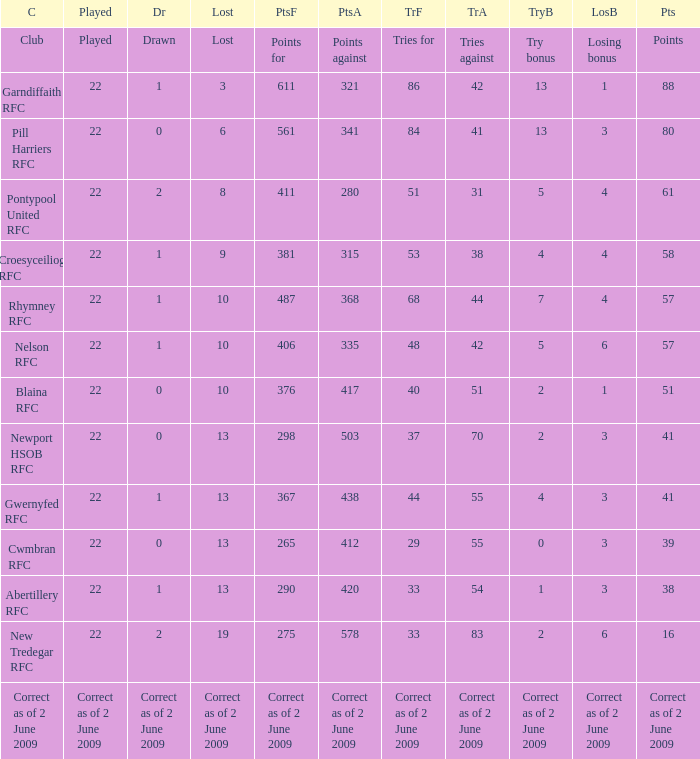How many tries against did the club with 1 drawn and 41 points have? 55.0. 